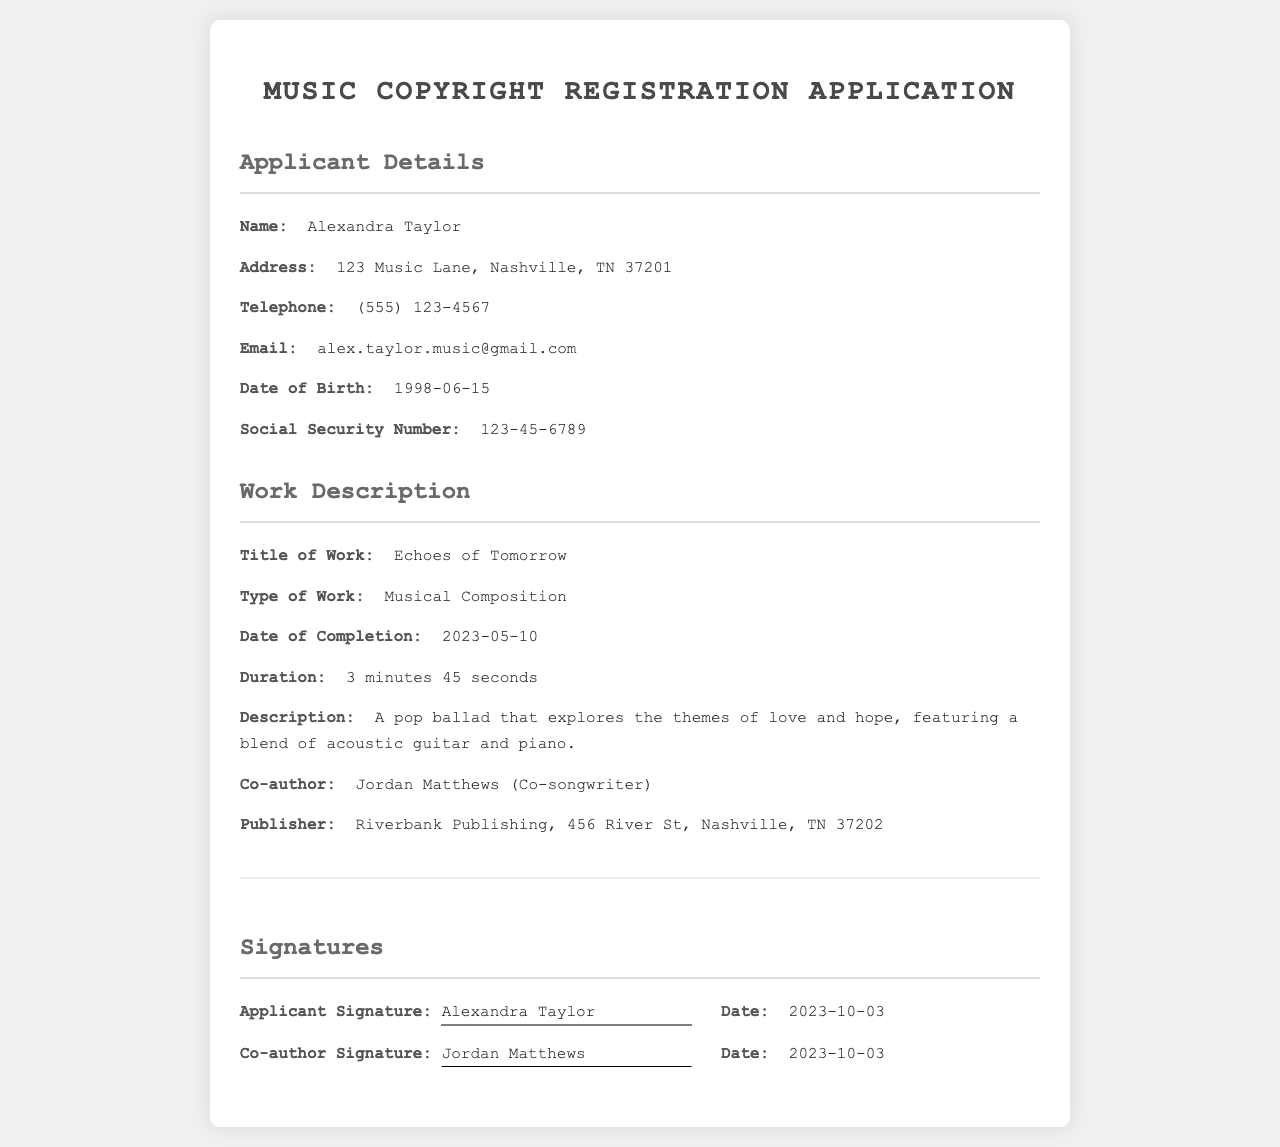What is the applicant's name? The applicant's name is listed in the document under the "Applicant Details" section.
Answer: Alexandra Taylor What is the telephone number of the applicant? The telephone number is provided in the "Applicant Details" section.
Answer: (555) 123-4567 What is the title of the musical work? The title of the work appears in the "Work Description" section of the document.
Answer: Echoes of Tomorrow Who is the co-author? The co-author's name is mentioned in the "Work Description" section.
Answer: Jordan Matthews What is the date of completion for the work? The completion date is specified in the "Work Description" section.
Answer: 2023-05-10 What is the publisher's address? The address of the publisher is provided in the "Work Description" section.
Answer: 456 River St, Nashville, TN 37202 How long is the musical composition? The duration of the work is detailed in the "Work Description" section.
Answer: 3 minutes 45 seconds On what date was the applicant's signature signed? The date of the applicant's signature is found in the "Signatures" section.
Answer: 2023-10-03 What type of work is registered? The type of work is indicated in the "Work Description" section.
Answer: Musical Composition 